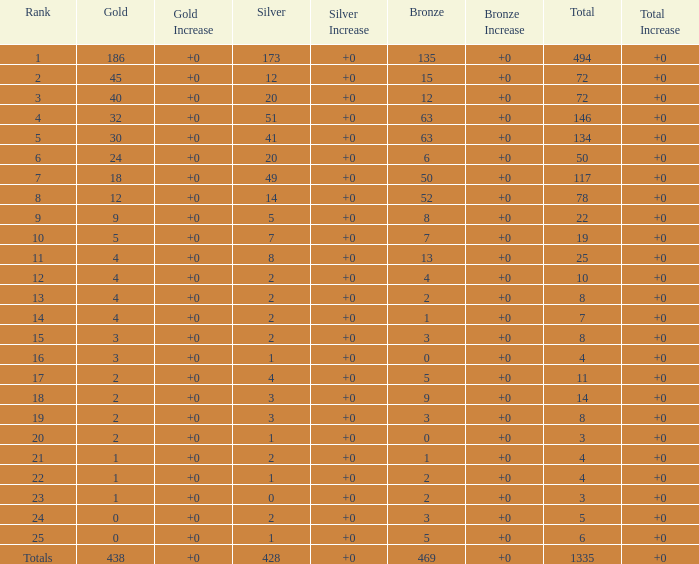What is the number of bronze medals when the total medals were 78 and there were less than 12 golds? None. 